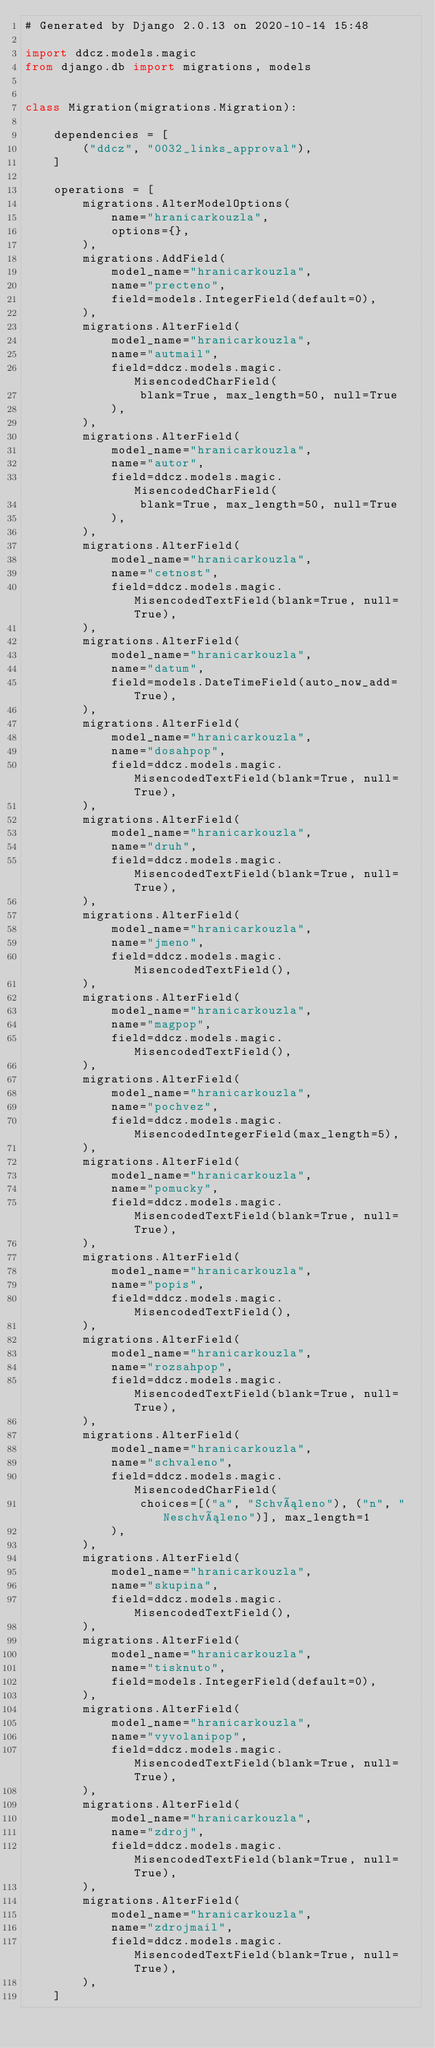Convert code to text. <code><loc_0><loc_0><loc_500><loc_500><_Python_># Generated by Django 2.0.13 on 2020-10-14 15:48

import ddcz.models.magic
from django.db import migrations, models


class Migration(migrations.Migration):

    dependencies = [
        ("ddcz", "0032_links_approval"),
    ]

    operations = [
        migrations.AlterModelOptions(
            name="hranicarkouzla",
            options={},
        ),
        migrations.AddField(
            model_name="hranicarkouzla",
            name="precteno",
            field=models.IntegerField(default=0),
        ),
        migrations.AlterField(
            model_name="hranicarkouzla",
            name="autmail",
            field=ddcz.models.magic.MisencodedCharField(
                blank=True, max_length=50, null=True
            ),
        ),
        migrations.AlterField(
            model_name="hranicarkouzla",
            name="autor",
            field=ddcz.models.magic.MisencodedCharField(
                blank=True, max_length=50, null=True
            ),
        ),
        migrations.AlterField(
            model_name="hranicarkouzla",
            name="cetnost",
            field=ddcz.models.magic.MisencodedTextField(blank=True, null=True),
        ),
        migrations.AlterField(
            model_name="hranicarkouzla",
            name="datum",
            field=models.DateTimeField(auto_now_add=True),
        ),
        migrations.AlterField(
            model_name="hranicarkouzla",
            name="dosahpop",
            field=ddcz.models.magic.MisencodedTextField(blank=True, null=True),
        ),
        migrations.AlterField(
            model_name="hranicarkouzla",
            name="druh",
            field=ddcz.models.magic.MisencodedTextField(blank=True, null=True),
        ),
        migrations.AlterField(
            model_name="hranicarkouzla",
            name="jmeno",
            field=ddcz.models.magic.MisencodedTextField(),
        ),
        migrations.AlterField(
            model_name="hranicarkouzla",
            name="magpop",
            field=ddcz.models.magic.MisencodedTextField(),
        ),
        migrations.AlterField(
            model_name="hranicarkouzla",
            name="pochvez",
            field=ddcz.models.magic.MisencodedIntegerField(max_length=5),
        ),
        migrations.AlterField(
            model_name="hranicarkouzla",
            name="pomucky",
            field=ddcz.models.magic.MisencodedTextField(blank=True, null=True),
        ),
        migrations.AlterField(
            model_name="hranicarkouzla",
            name="popis",
            field=ddcz.models.magic.MisencodedTextField(),
        ),
        migrations.AlterField(
            model_name="hranicarkouzla",
            name="rozsahpop",
            field=ddcz.models.magic.MisencodedTextField(blank=True, null=True),
        ),
        migrations.AlterField(
            model_name="hranicarkouzla",
            name="schvaleno",
            field=ddcz.models.magic.MisencodedCharField(
                choices=[("a", "Schváleno"), ("n", "Neschváleno")], max_length=1
            ),
        ),
        migrations.AlterField(
            model_name="hranicarkouzla",
            name="skupina",
            field=ddcz.models.magic.MisencodedTextField(),
        ),
        migrations.AlterField(
            model_name="hranicarkouzla",
            name="tisknuto",
            field=models.IntegerField(default=0),
        ),
        migrations.AlterField(
            model_name="hranicarkouzla",
            name="vyvolanipop",
            field=ddcz.models.magic.MisencodedTextField(blank=True, null=True),
        ),
        migrations.AlterField(
            model_name="hranicarkouzla",
            name="zdroj",
            field=ddcz.models.magic.MisencodedTextField(blank=True, null=True),
        ),
        migrations.AlterField(
            model_name="hranicarkouzla",
            name="zdrojmail",
            field=ddcz.models.magic.MisencodedTextField(blank=True, null=True),
        ),
    ]
</code> 